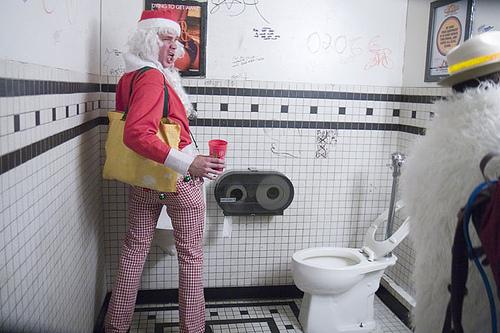What room is this?
Short answer required. Bathroom. What is the man dressed as?
Short answer required. Santa. Is there graffiti on the wall?
Short answer required. Yes. 